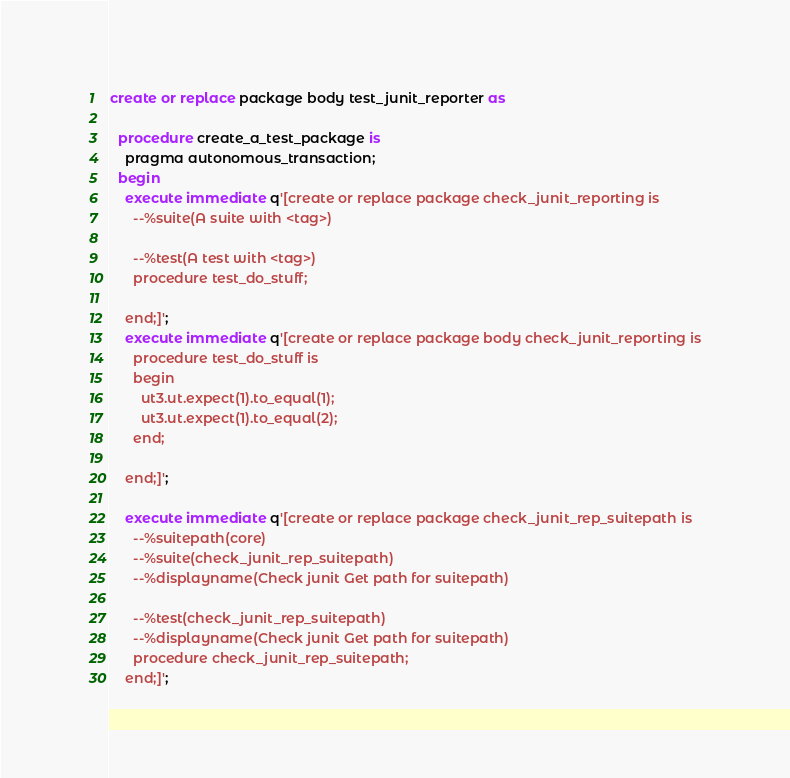<code> <loc_0><loc_0><loc_500><loc_500><_SQL_>create or replace package body test_junit_reporter as

  procedure create_a_test_package is
    pragma autonomous_transaction;
  begin
    execute immediate q'[create or replace package check_junit_reporting is
      --%suite(A suite with <tag>)

      --%test(A test with <tag>)
      procedure test_do_stuff;
      
    end;]';
    execute immediate q'[create or replace package body check_junit_reporting is
      procedure test_do_stuff is
      begin
        ut3.ut.expect(1).to_equal(1);
        ut3.ut.expect(1).to_equal(2);
      end;

    end;]';
    
    execute immediate q'[create or replace package check_junit_rep_suitepath is
      --%suitepath(core)
      --%suite(check_junit_rep_suitepath)
      --%displayname(Check junit Get path for suitepath)
            
      --%test(check_junit_rep_suitepath)
      --%displayname(Check junit Get path for suitepath)
      procedure check_junit_rep_suitepath;
    end;]';</code> 